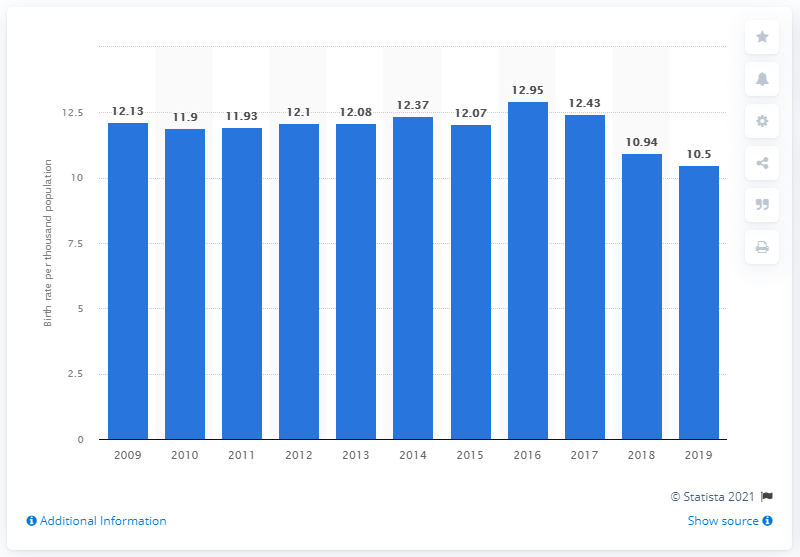List a handful of essential elements in this visual. The crude birth rate in China in 2019 was 10.5. 